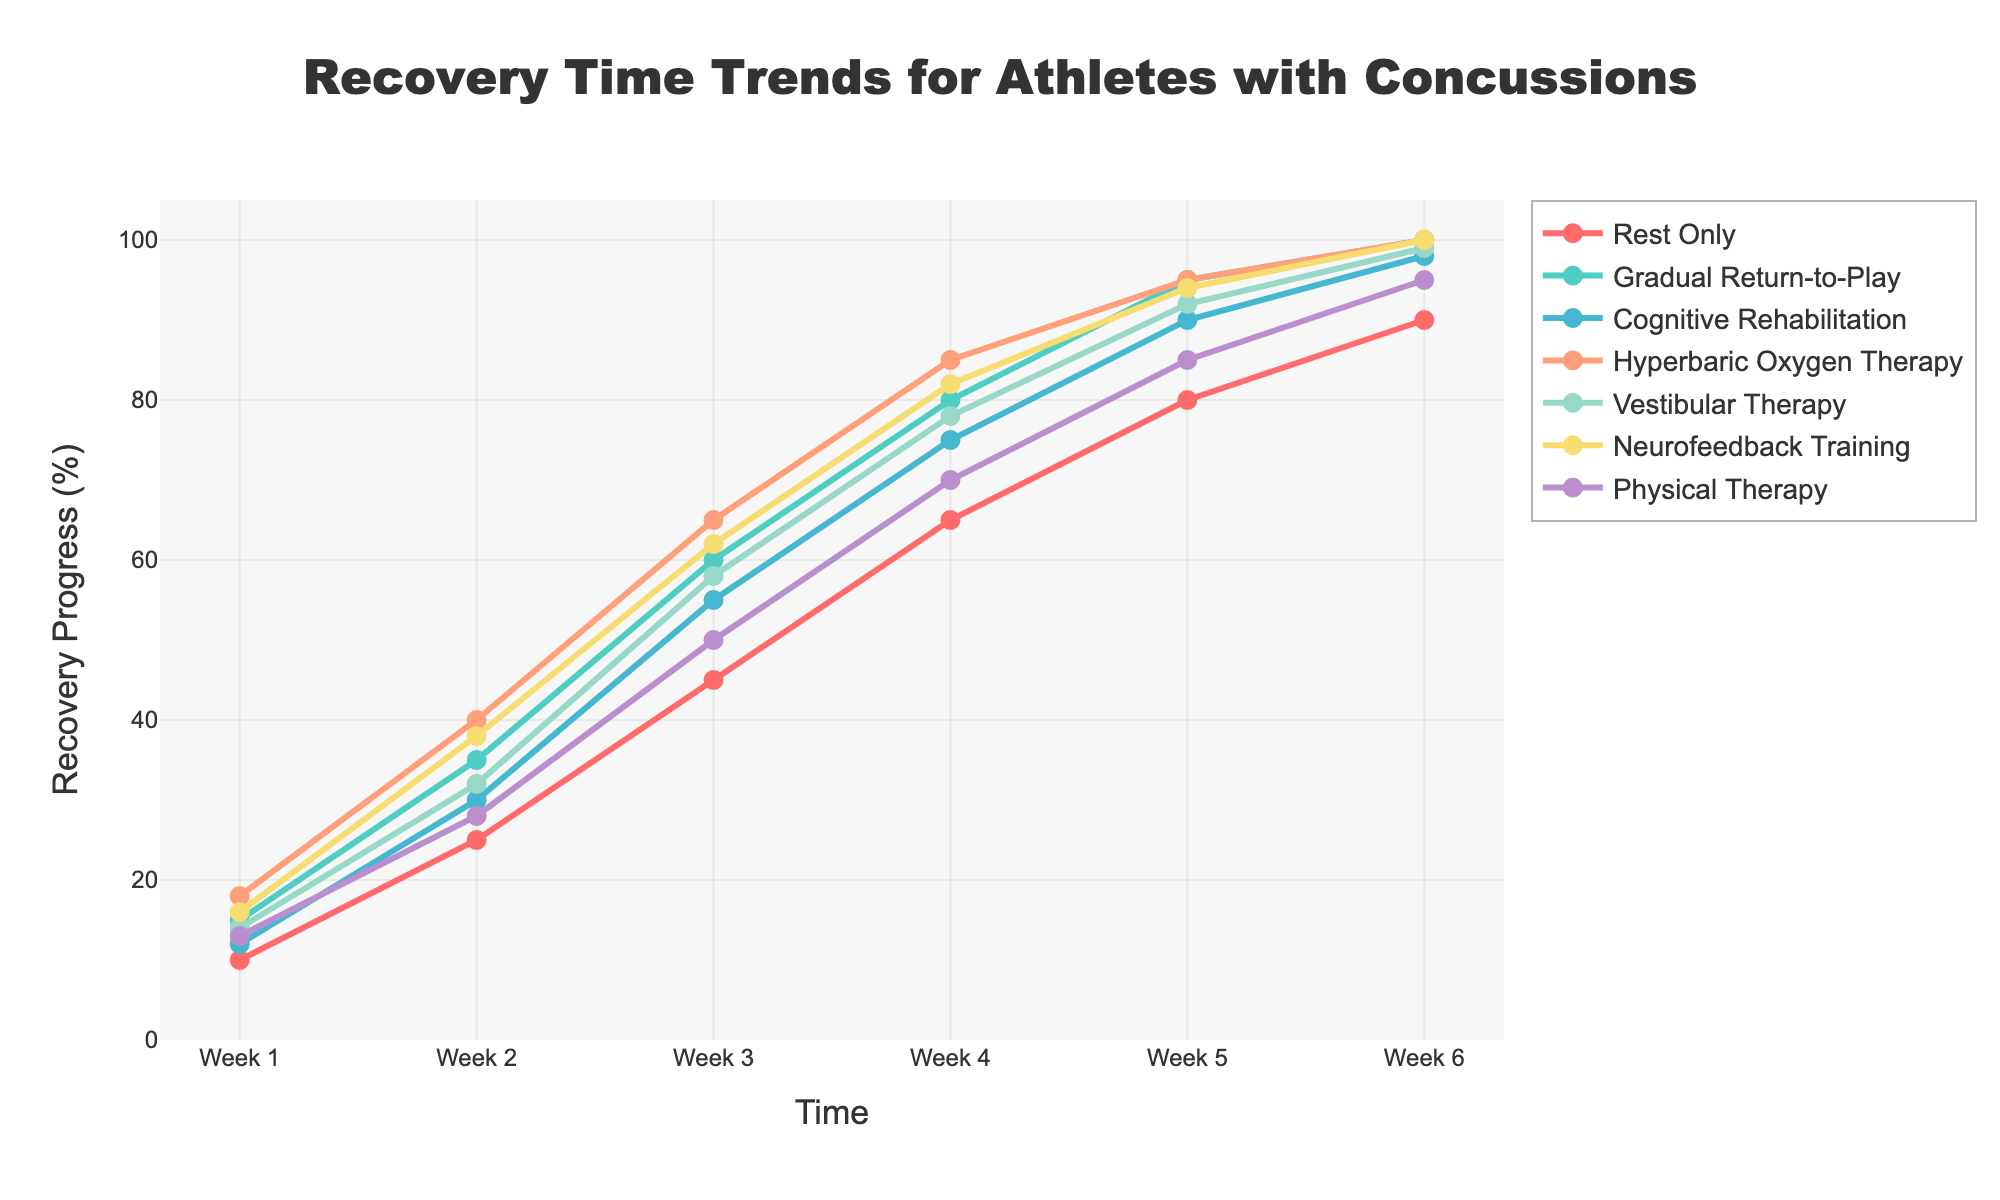Which treatment protocol shows the fastest recovery by Week 6? To determine the fastest recovery by Week 6, we need to look at the recovery progress percentages for all protocols at Week 6. The protocols "Gradual Return-to-Play", "Hyperbaric Oxygen Therapy", "Neurofeedback Training" all show 100% recovery.
Answer: Gradual Return-to-Play, Hyperbaric Oxygen Therapy, Neurofeedback Training Which protocol shows the slowest initial recovery in Week 1? The initial recovery in Week 1 can be determined by looking at the Week 1 data points. The "Rest Only" protocol shows the slowest initial recovery with 10%.
Answer: Rest Only By Week 3, which treatment protocol has surpassed 50% recovery? We need to identify protocols with recovery percentages greater than 50% in Week 3. Both "Gradual Return-to-Play" (60) and "Hyperbaric Oxygen Therapy" (65) exceed 50%.
Answer: Gradual Return-to-Play, Hyperbaric Oxygen Therapy Out of Vestibular Therapy and Physical Therapy, which one shows a higher recovery rate in Week 5? Compare the recovery progress for Vestibular Therapy (92%) and Physical Therapy (85%) at Week 5.
Answer: Vestibular Therapy What is the average recovery progress by Week 4 across all treatment protocols? Sum up all recovery percentages at Week 4 and divide by the number of protocols: (65 + 80 + 75 + 85 + 78 + 82 + 70) / 7. The result is (535 / 7).
Answer: 76.43 By how many percentage points does Neurofeedback Training outperform Cognitive Rehabilitation in Week 6? Find the difference in recovery progress between Neurofeedback Training (100) and Cognitive Rehabilitation (98) at Week 6. The difference is 100 - 98 = 2.
Answer: 2 What is the color of the line representing Physical Therapy? Identify the visual attribute of the line for Physical Therapy in the chart, which is represented in purple.
Answer: purple Which treatment shows a linear increase in recovery progress, and how can you tell from the graph? A linear increase can be identified by the equal increments in recovery percentage throughout the weeks. "Neurofeedback Training" shows consistent increments: 16, 38, 62, 82, 94, 100.
Answer: Neurofeedback Training At what week does the Rest Only protocol reach 50% recovery? Look at the recovery percentage for the Rest Only protocol across the weeks. The Rest Only protocol reaches 50% in Week 3 with a percentage of 45.
Answer: Never By Week 4, how many treatments have reached or surpassed an 80% recovery rate? Identify the treatments and their corresponding recovery rates in Week 4: Gradual Return-to-Play (80), Hyperbaric Oxygen Therapy (85), Neurofeedback Training (82), Vestibular Therapy (78), which makes 3 treatments.
Answer: 3 